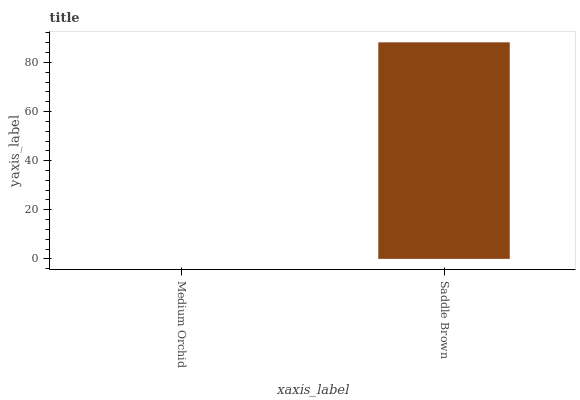Is Saddle Brown the minimum?
Answer yes or no. No. Is Saddle Brown greater than Medium Orchid?
Answer yes or no. Yes. Is Medium Orchid less than Saddle Brown?
Answer yes or no. Yes. Is Medium Orchid greater than Saddle Brown?
Answer yes or no. No. Is Saddle Brown less than Medium Orchid?
Answer yes or no. No. Is Saddle Brown the high median?
Answer yes or no. Yes. Is Medium Orchid the low median?
Answer yes or no. Yes. Is Medium Orchid the high median?
Answer yes or no. No. Is Saddle Brown the low median?
Answer yes or no. No. 